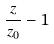Convert formula to latex. <formula><loc_0><loc_0><loc_500><loc_500>\frac { z } { z _ { 0 } } - 1</formula> 